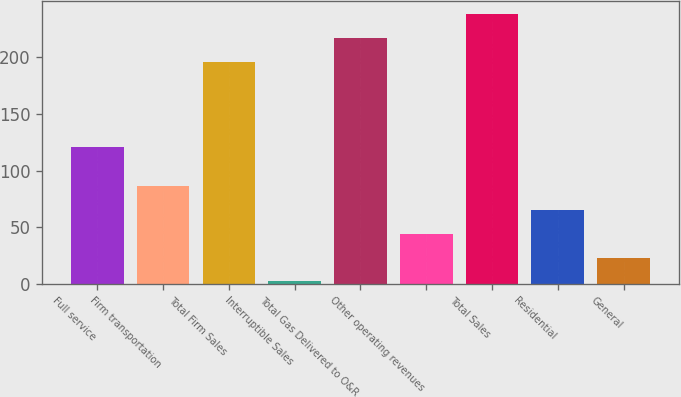Convert chart. <chart><loc_0><loc_0><loc_500><loc_500><bar_chart><fcel>Full service<fcel>Firm transportation<fcel>Total Firm Sales<fcel>Interruptible Sales<fcel>Total Gas Delivered to O&R<fcel>Other operating revenues<fcel>Total Sales<fcel>Residential<fcel>General<nl><fcel>121<fcel>86<fcel>196<fcel>2<fcel>217<fcel>44<fcel>238<fcel>65<fcel>23<nl></chart> 